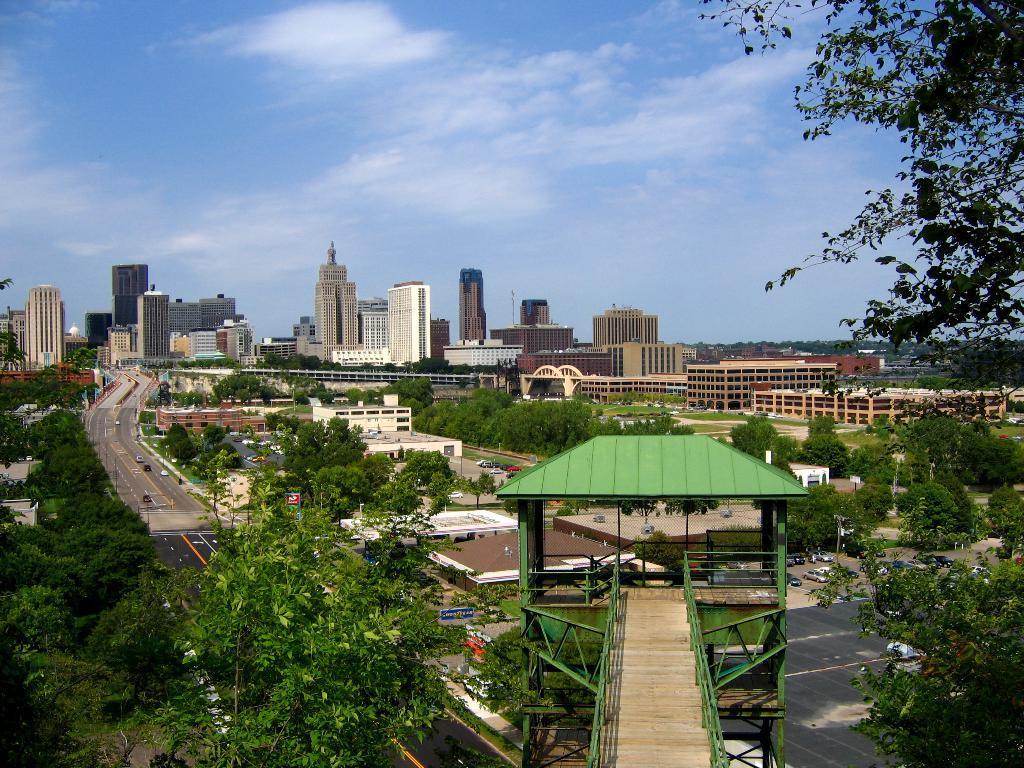How would you summarize this image in a sentence or two? As we can see in the image there is bridge, trees, vehicles and buildings. At the top there is sky and clouds. 